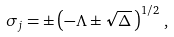Convert formula to latex. <formula><loc_0><loc_0><loc_500><loc_500>\sigma _ { j } = \pm \left ( - \Lambda \pm \sqrt { \Delta } \, \right ) ^ { 1 / 2 } \, ,</formula> 